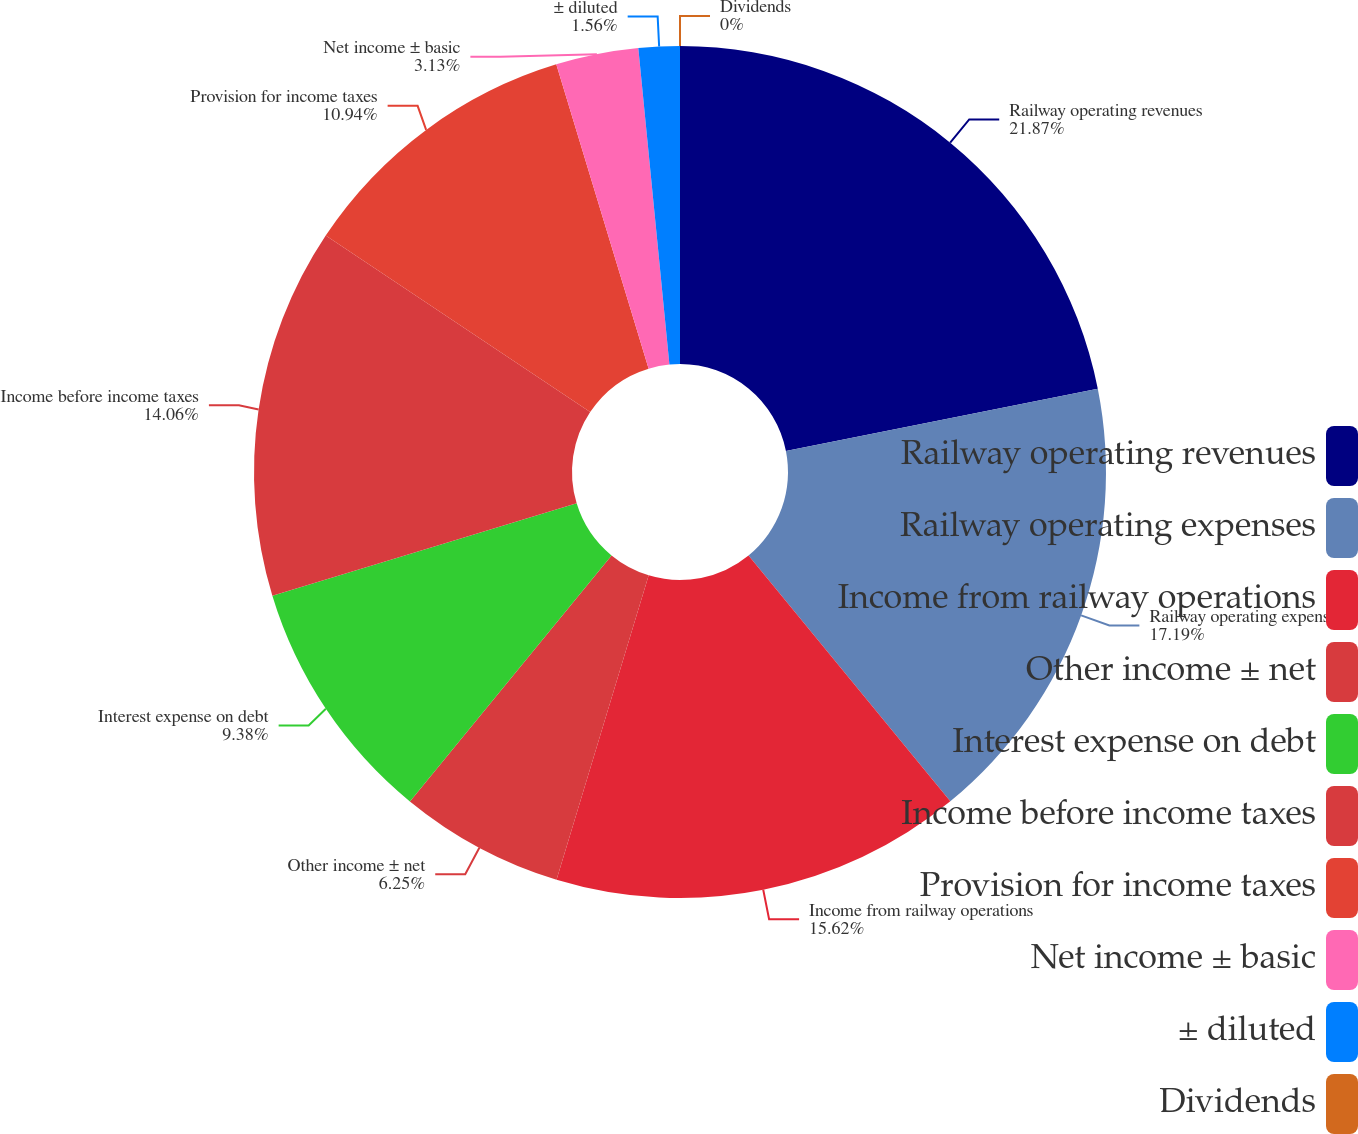Convert chart to OTSL. <chart><loc_0><loc_0><loc_500><loc_500><pie_chart><fcel>Railway operating revenues<fcel>Railway operating expenses<fcel>Income from railway operations<fcel>Other income ± net<fcel>Interest expense on debt<fcel>Income before income taxes<fcel>Provision for income taxes<fcel>Net income ± basic<fcel>± diluted<fcel>Dividends<nl><fcel>21.87%<fcel>17.19%<fcel>15.62%<fcel>6.25%<fcel>9.38%<fcel>14.06%<fcel>10.94%<fcel>3.13%<fcel>1.56%<fcel>0.0%<nl></chart> 